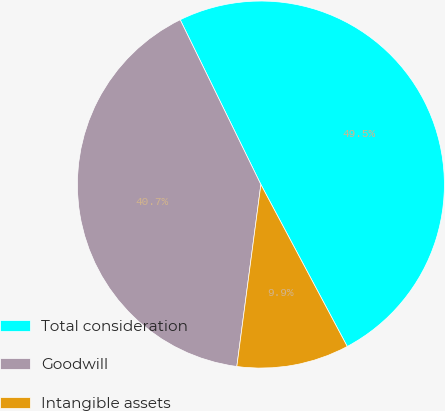<chart> <loc_0><loc_0><loc_500><loc_500><pie_chart><fcel>Total consideration<fcel>Goodwill<fcel>Intangible assets<nl><fcel>49.45%<fcel>40.66%<fcel>9.89%<nl></chart> 